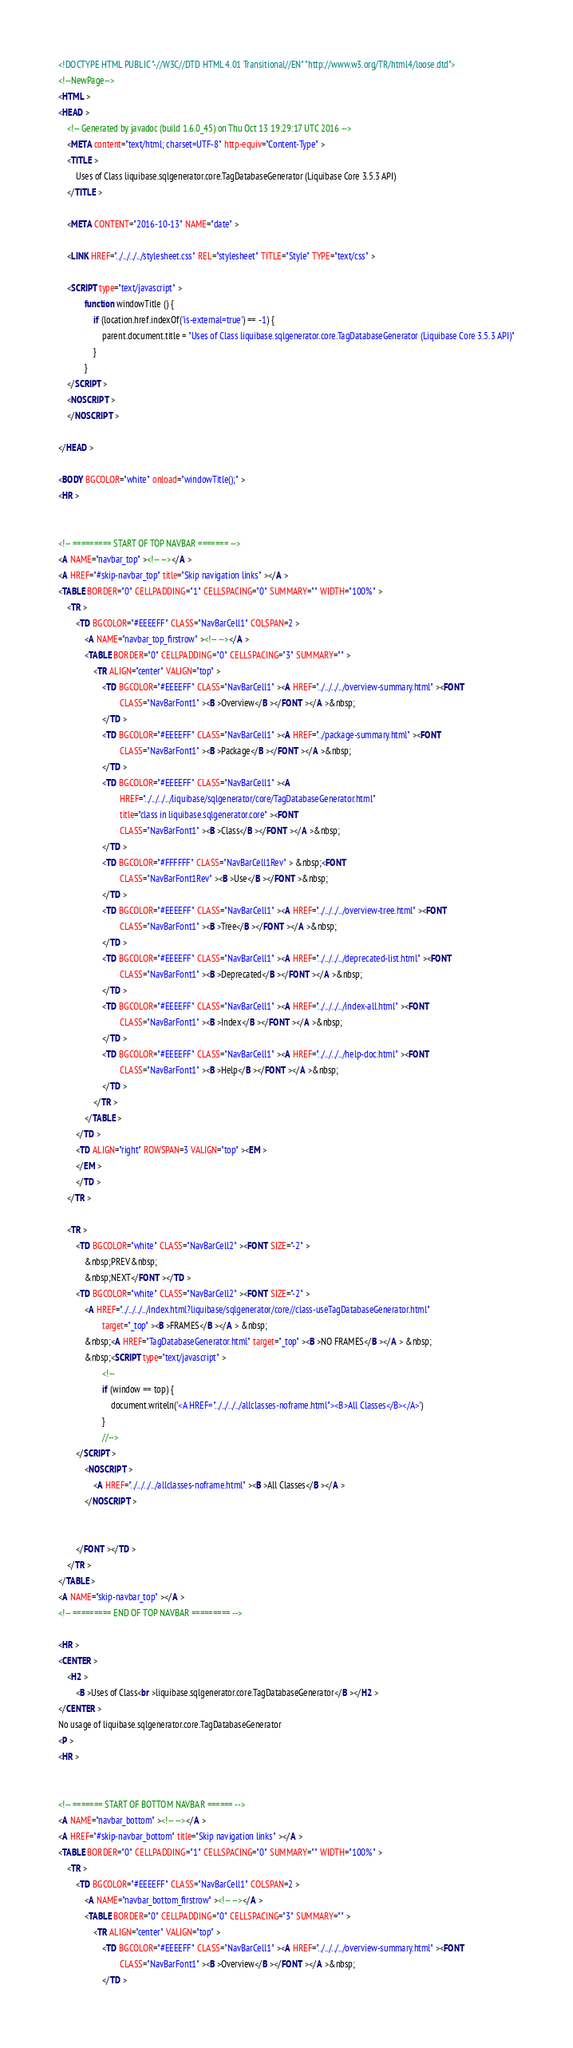Convert code to text. <code><loc_0><loc_0><loc_500><loc_500><_HTML_><!DOCTYPE HTML PUBLIC "-//W3C//DTD HTML 4.01 Transitional//EN" "http://www.w3.org/TR/html4/loose.dtd">
<!--NewPage-->
<HTML >
<HEAD >
    <!-- Generated by javadoc (build 1.6.0_45) on Thu Oct 13 19:29:17 UTC 2016 -->
    <META content="text/html; charset=UTF-8" http-equiv="Content-Type" >
    <TITLE >
        Uses of Class liquibase.sqlgenerator.core.TagDatabaseGenerator (Liquibase Core 3.5.3 API)
    </TITLE >

    <META CONTENT="2016-10-13" NAME="date" >

    <LINK HREF="../../../../stylesheet.css" REL="stylesheet" TITLE="Style" TYPE="text/css" >

    <SCRIPT type="text/javascript" >
			function windowTitle () {
				if (location.href.indexOf('is-external=true') == -1) {
					parent.document.title = "Uses of Class liquibase.sqlgenerator.core.TagDatabaseGenerator (Liquibase Core 3.5.3 API)"
				}
			}
    </SCRIPT >
    <NOSCRIPT >
    </NOSCRIPT >

</HEAD >

<BODY BGCOLOR="white" onload="windowTitle();" >
<HR >


<!-- ========= START OF TOP NAVBAR ======= -->
<A NAME="navbar_top" ><!-- --></A >
<A HREF="#skip-navbar_top" title="Skip navigation links" ></A >
<TABLE BORDER="0" CELLPADDING="1" CELLSPACING="0" SUMMARY="" WIDTH="100%" >
    <TR >
        <TD BGCOLOR="#EEEEFF" CLASS="NavBarCell1" COLSPAN=2 >
            <A NAME="navbar_top_firstrow" ><!-- --></A >
            <TABLE BORDER="0" CELLPADDING="0" CELLSPACING="3" SUMMARY="" >
                <TR ALIGN="center" VALIGN="top" >
                    <TD BGCOLOR="#EEEEFF" CLASS="NavBarCell1" ><A HREF="../../../../overview-summary.html" ><FONT
                            CLASS="NavBarFont1" ><B >Overview</B ></FONT ></A >&nbsp;
                    </TD >
                    <TD BGCOLOR="#EEEEFF" CLASS="NavBarCell1" ><A HREF="../package-summary.html" ><FONT
                            CLASS="NavBarFont1" ><B >Package</B ></FONT ></A >&nbsp;
                    </TD >
                    <TD BGCOLOR="#EEEEFF" CLASS="NavBarCell1" ><A
                            HREF="../../../../liquibase/sqlgenerator/core/TagDatabaseGenerator.html"
                            title="class in liquibase.sqlgenerator.core" ><FONT
                            CLASS="NavBarFont1" ><B >Class</B ></FONT ></A >&nbsp;
                    </TD >
                    <TD BGCOLOR="#FFFFFF" CLASS="NavBarCell1Rev" > &nbsp;<FONT
                            CLASS="NavBarFont1Rev" ><B >Use</B ></FONT >&nbsp;
                    </TD >
                    <TD BGCOLOR="#EEEEFF" CLASS="NavBarCell1" ><A HREF="../../../../overview-tree.html" ><FONT
                            CLASS="NavBarFont1" ><B >Tree</B ></FONT ></A >&nbsp;
                    </TD >
                    <TD BGCOLOR="#EEEEFF" CLASS="NavBarCell1" ><A HREF="../../../../deprecated-list.html" ><FONT
                            CLASS="NavBarFont1" ><B >Deprecated</B ></FONT ></A >&nbsp;
                    </TD >
                    <TD BGCOLOR="#EEEEFF" CLASS="NavBarCell1" ><A HREF="../../../../index-all.html" ><FONT
                            CLASS="NavBarFont1" ><B >Index</B ></FONT ></A >&nbsp;
                    </TD >
                    <TD BGCOLOR="#EEEEFF" CLASS="NavBarCell1" ><A HREF="../../../../help-doc.html" ><FONT
                            CLASS="NavBarFont1" ><B >Help</B ></FONT ></A >&nbsp;
                    </TD >
                </TR >
            </TABLE >
        </TD >
        <TD ALIGN="right" ROWSPAN=3 VALIGN="top" ><EM >
        </EM >
        </TD >
    </TR >

    <TR >
        <TD BGCOLOR="white" CLASS="NavBarCell2" ><FONT SIZE="-2" >
            &nbsp;PREV&nbsp;
            &nbsp;NEXT</FONT ></TD >
        <TD BGCOLOR="white" CLASS="NavBarCell2" ><FONT SIZE="-2" >
            <A HREF="../../../../index.html?liquibase/sqlgenerator/core//class-useTagDatabaseGenerator.html"
                    target="_top" ><B >FRAMES</B ></A > &nbsp;
            &nbsp;<A HREF="TagDatabaseGenerator.html" target="_top" ><B >NO FRAMES</B ></A > &nbsp;
            &nbsp;<SCRIPT type="text/javascript" >
					<!--
					if (window == top) {
						document.writeln('<A HREF="../../../../allclasses-noframe.html"><B>All Classes</B></A>')
					}
					//-->
        </SCRIPT >
            <NOSCRIPT >
                <A HREF="../../../../allclasses-noframe.html" ><B >All Classes</B ></A >
            </NOSCRIPT >


        </FONT ></TD >
    </TR >
</TABLE >
<A NAME="skip-navbar_top" ></A >
<!-- ========= END OF TOP NAVBAR ========= -->

<HR >
<CENTER >
    <H2 >
        <B >Uses of Class<br >liquibase.sqlgenerator.core.TagDatabaseGenerator</B ></H2 >
</CENTER >
No usage of liquibase.sqlgenerator.core.TagDatabaseGenerator
<P >
<HR >


<!-- ======= START OF BOTTOM NAVBAR ====== -->
<A NAME="navbar_bottom" ><!-- --></A >
<A HREF="#skip-navbar_bottom" title="Skip navigation links" ></A >
<TABLE BORDER="0" CELLPADDING="1" CELLSPACING="0" SUMMARY="" WIDTH="100%" >
    <TR >
        <TD BGCOLOR="#EEEEFF" CLASS="NavBarCell1" COLSPAN=2 >
            <A NAME="navbar_bottom_firstrow" ><!-- --></A >
            <TABLE BORDER="0" CELLPADDING="0" CELLSPACING="3" SUMMARY="" >
                <TR ALIGN="center" VALIGN="top" >
                    <TD BGCOLOR="#EEEEFF" CLASS="NavBarCell1" ><A HREF="../../../../overview-summary.html" ><FONT
                            CLASS="NavBarFont1" ><B >Overview</B ></FONT ></A >&nbsp;
                    </TD ></code> 